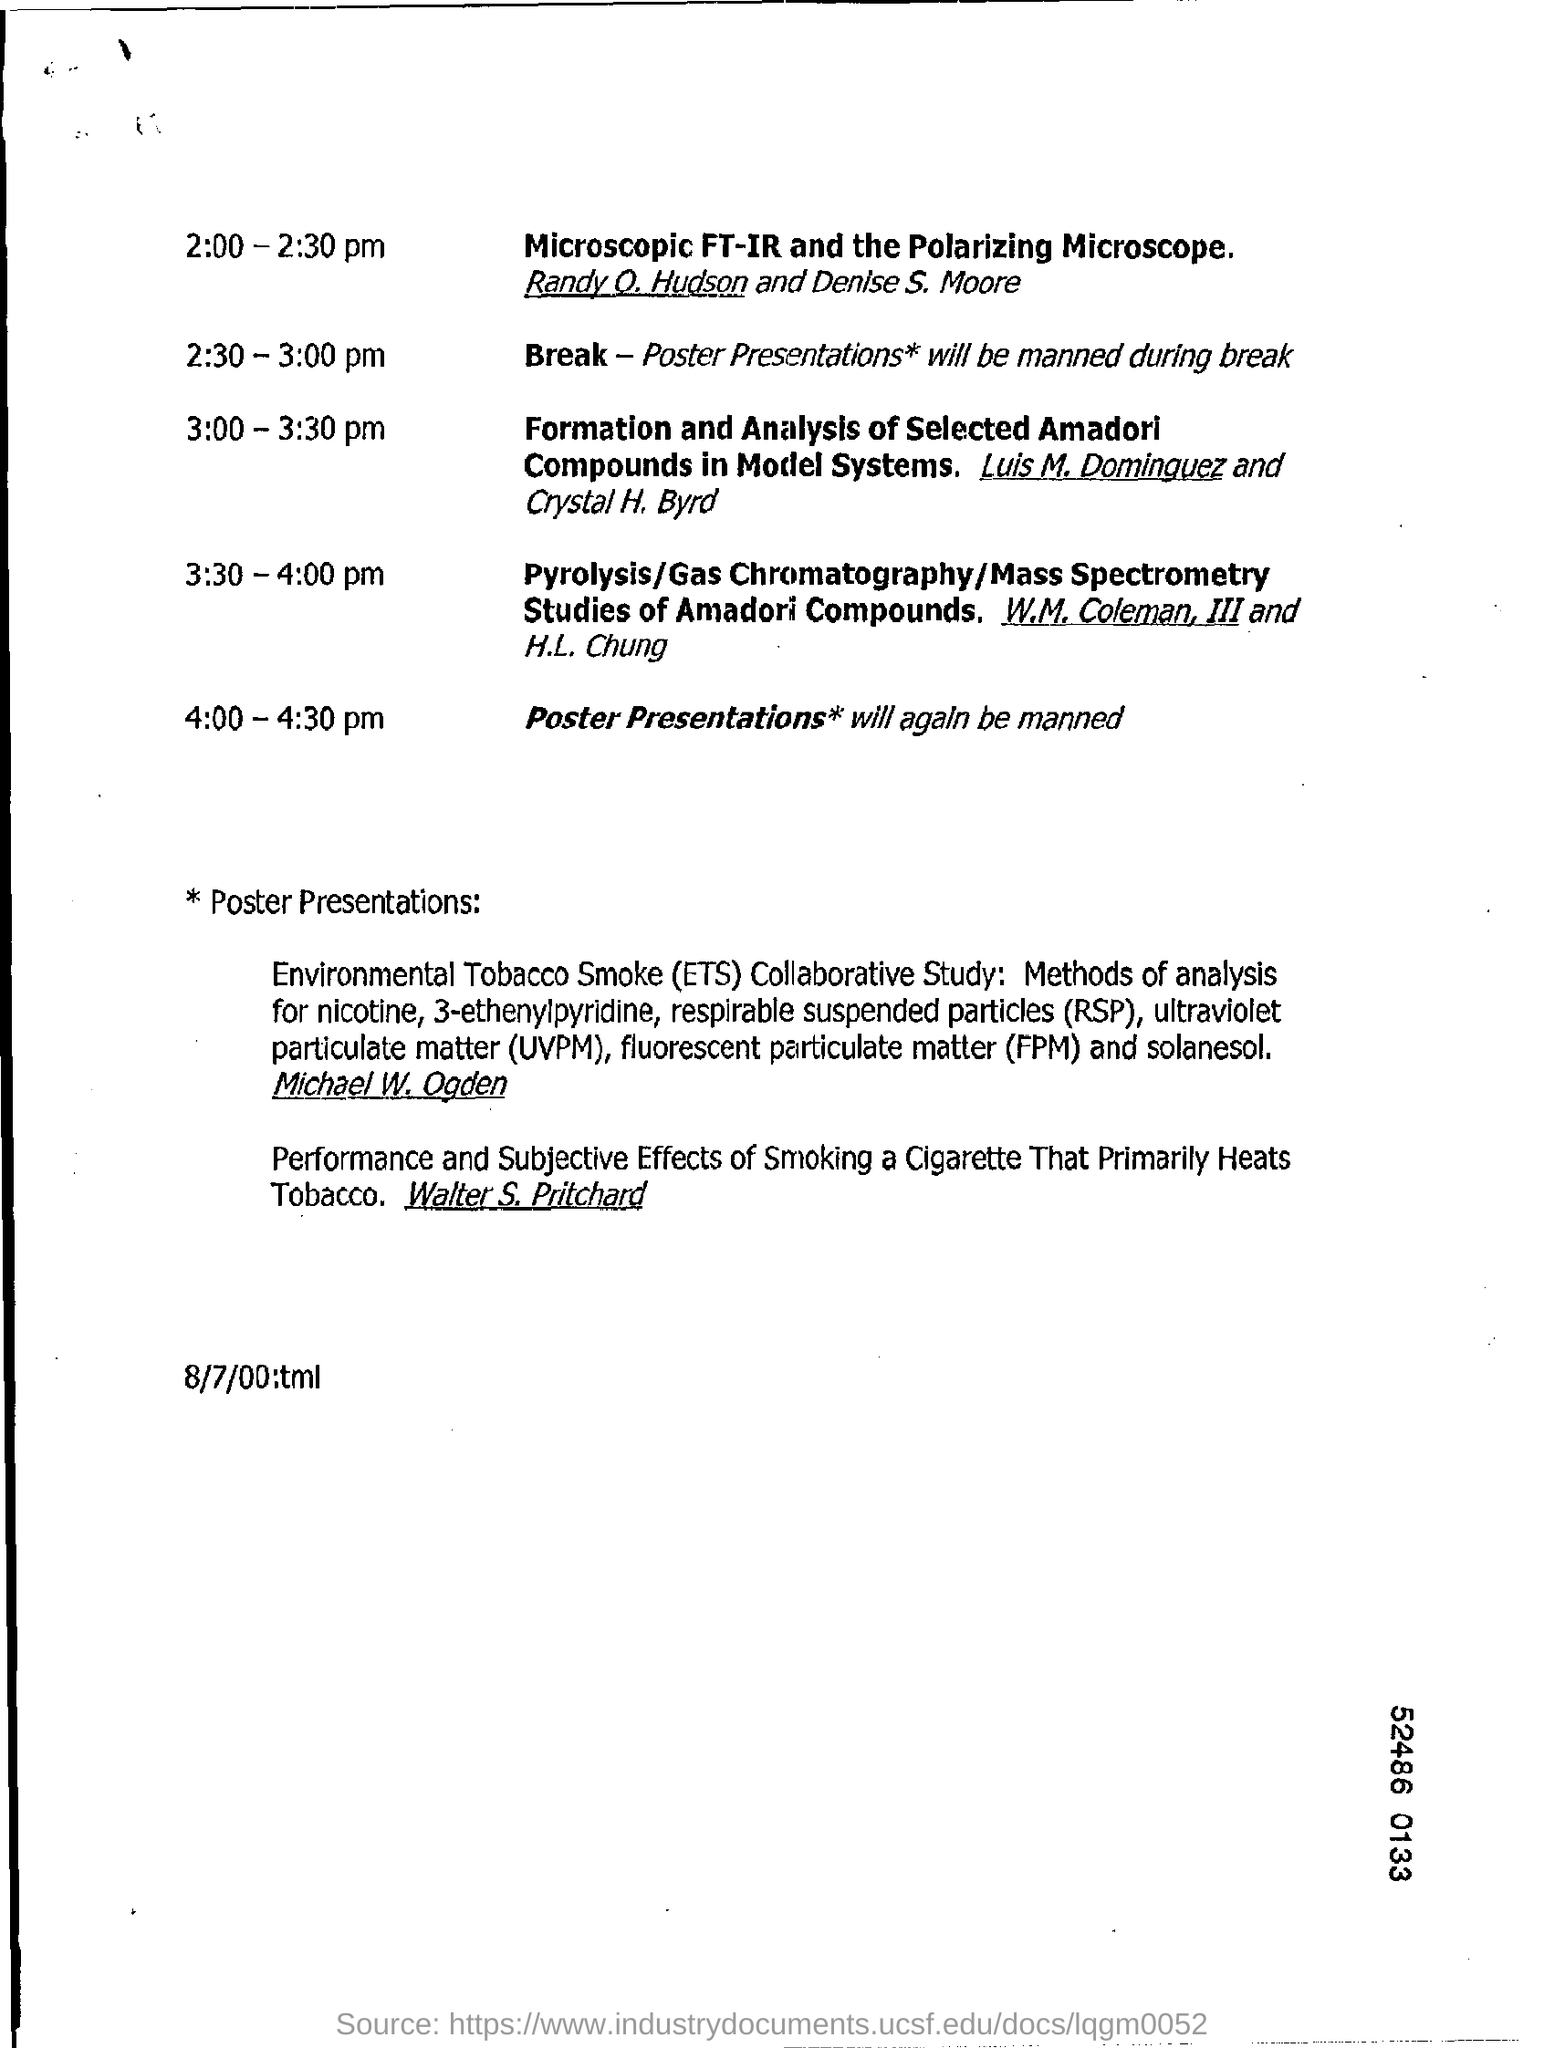List a handful of essential elements in this visual. Respirable suspended particles (RSP) are fine particles that are inhaled and can cause respiratory problems when breathed in. FPM stands for Fluorescent Particulate Matter. 